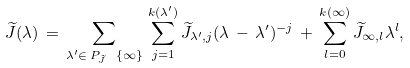Convert formula to latex. <formula><loc_0><loc_0><loc_500><loc_500>\widetilde { J } ( \lambda ) \, = \, \sum _ { \lambda ^ { \prime } \in \, P _ { \widetilde { J } } \ \{ \infty \} } \, \sum _ { j = 1 } ^ { k ( \lambda ^ { \prime } ) } \widetilde { J } _ { \lambda ^ { \prime } , j } ( \lambda \, - \, \lambda ^ { \prime } ) ^ { - j } \, + \, \sum _ { l = 0 } ^ { k ( \infty ) } \widetilde { J } _ { \infty , l } \lambda ^ { l } ,</formula> 